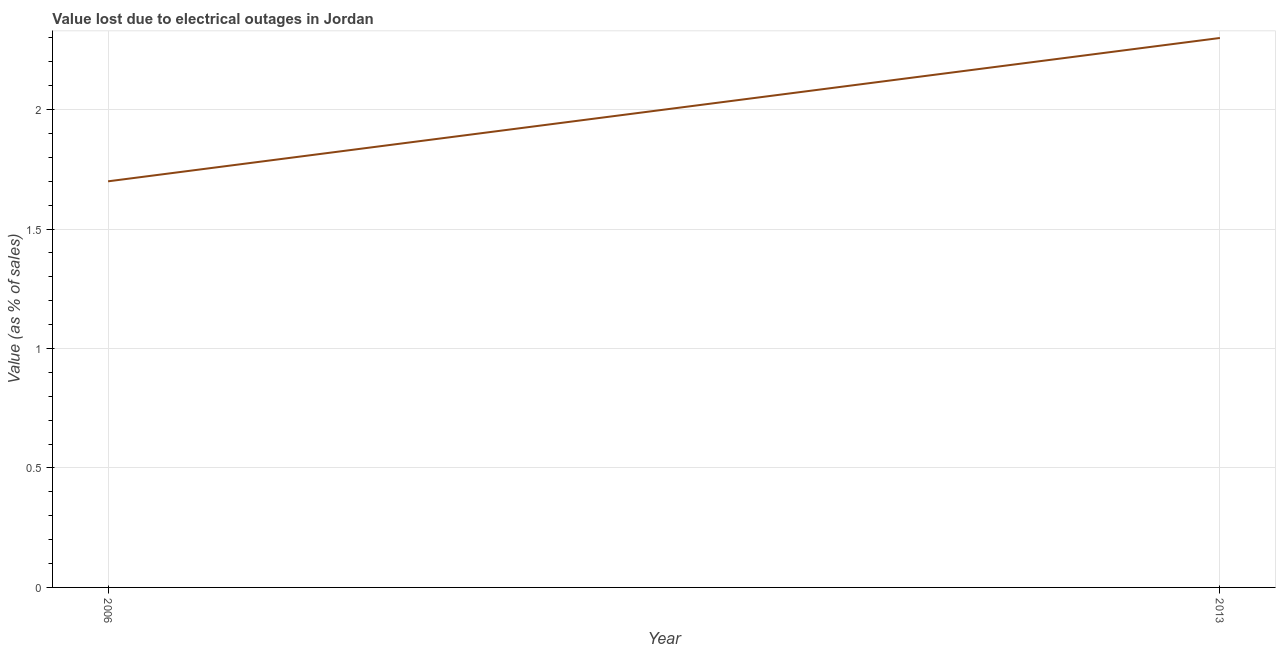Across all years, what is the maximum value lost due to electrical outages?
Your answer should be very brief. 2.3. Across all years, what is the minimum value lost due to electrical outages?
Make the answer very short. 1.7. In which year was the value lost due to electrical outages maximum?
Ensure brevity in your answer.  2013. In which year was the value lost due to electrical outages minimum?
Provide a short and direct response. 2006. What is the difference between the value lost due to electrical outages in 2006 and 2013?
Keep it short and to the point. -0.6. What is the median value lost due to electrical outages?
Keep it short and to the point. 2. In how many years, is the value lost due to electrical outages greater than 1.9 %?
Offer a terse response. 1. What is the ratio of the value lost due to electrical outages in 2006 to that in 2013?
Keep it short and to the point. 0.74. Is the value lost due to electrical outages in 2006 less than that in 2013?
Ensure brevity in your answer.  Yes. In how many years, is the value lost due to electrical outages greater than the average value lost due to electrical outages taken over all years?
Give a very brief answer. 1. How many years are there in the graph?
Your answer should be compact. 2. Are the values on the major ticks of Y-axis written in scientific E-notation?
Offer a terse response. No. Does the graph contain grids?
Your answer should be compact. Yes. What is the title of the graph?
Make the answer very short. Value lost due to electrical outages in Jordan. What is the label or title of the Y-axis?
Offer a very short reply. Value (as % of sales). What is the Value (as % of sales) of 2013?
Keep it short and to the point. 2.3. What is the ratio of the Value (as % of sales) in 2006 to that in 2013?
Give a very brief answer. 0.74. 